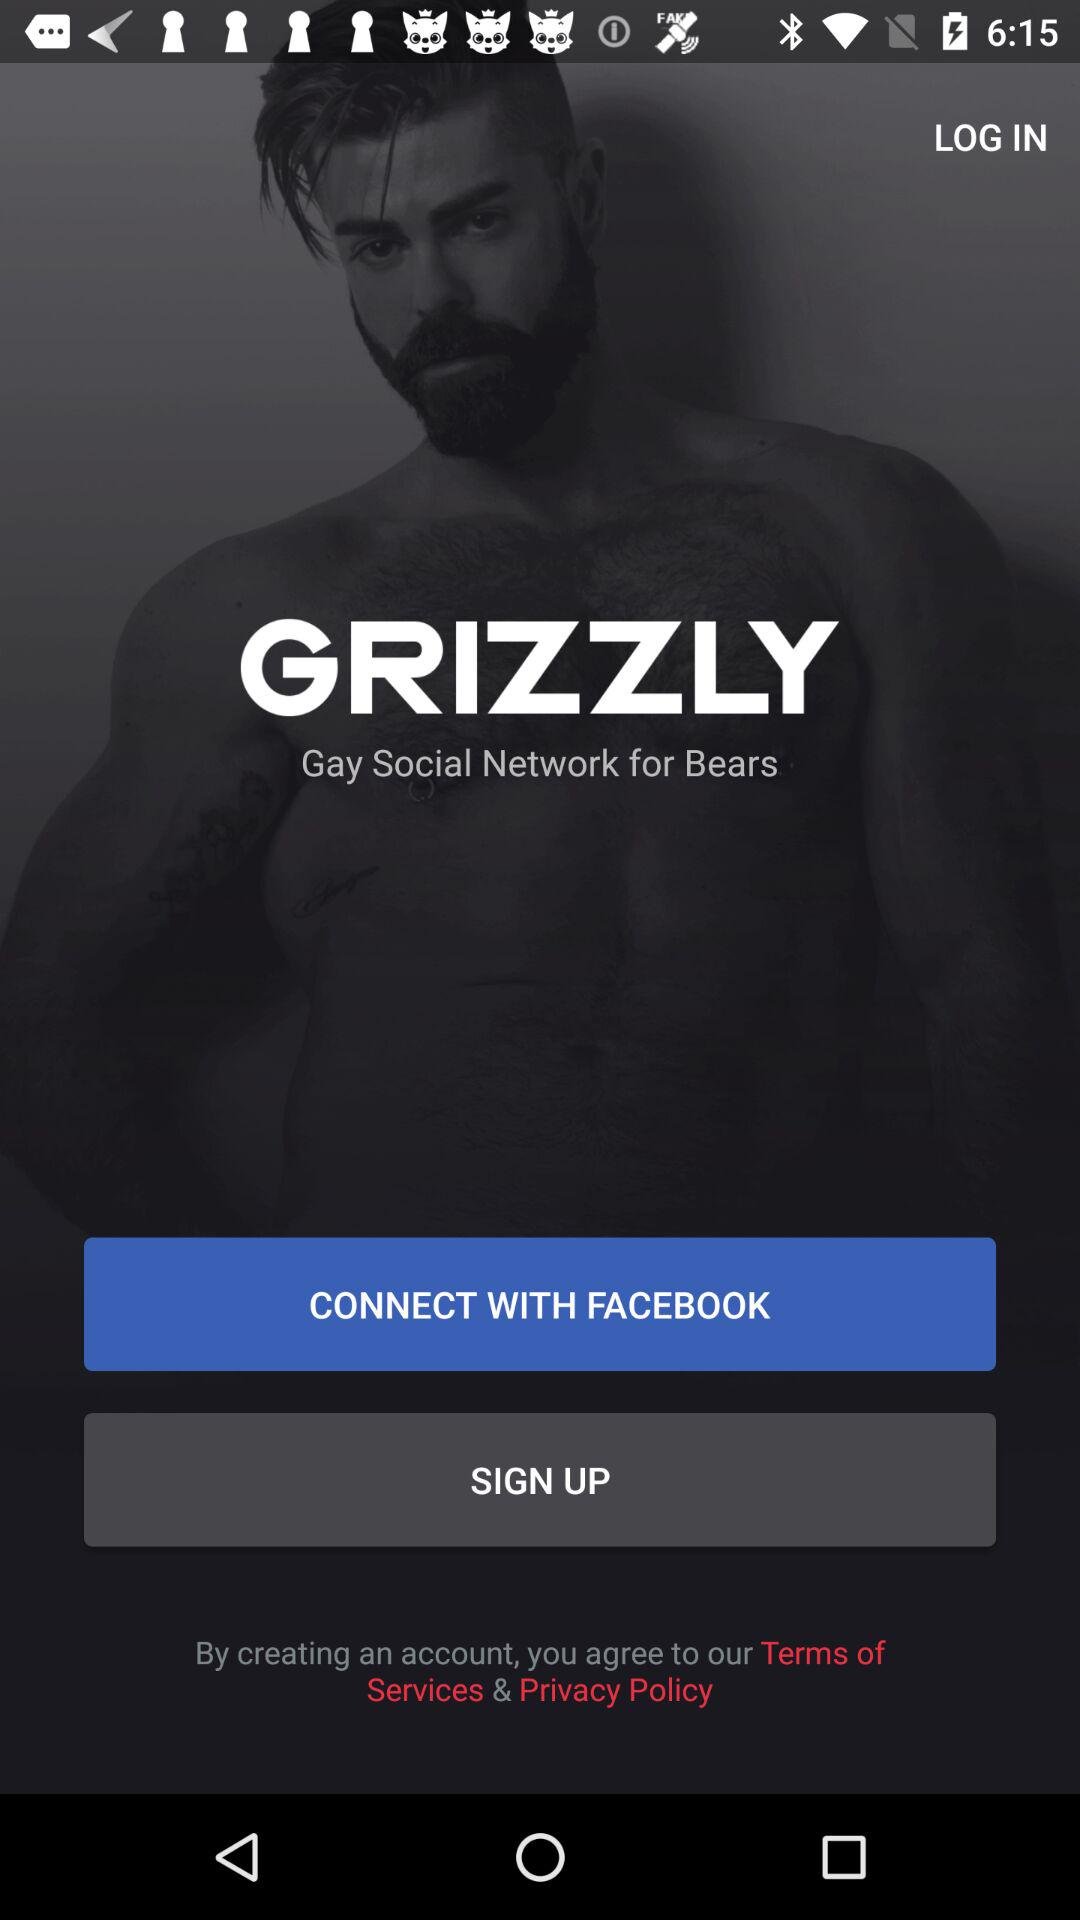What is the application name? The application name is Grizzly. 